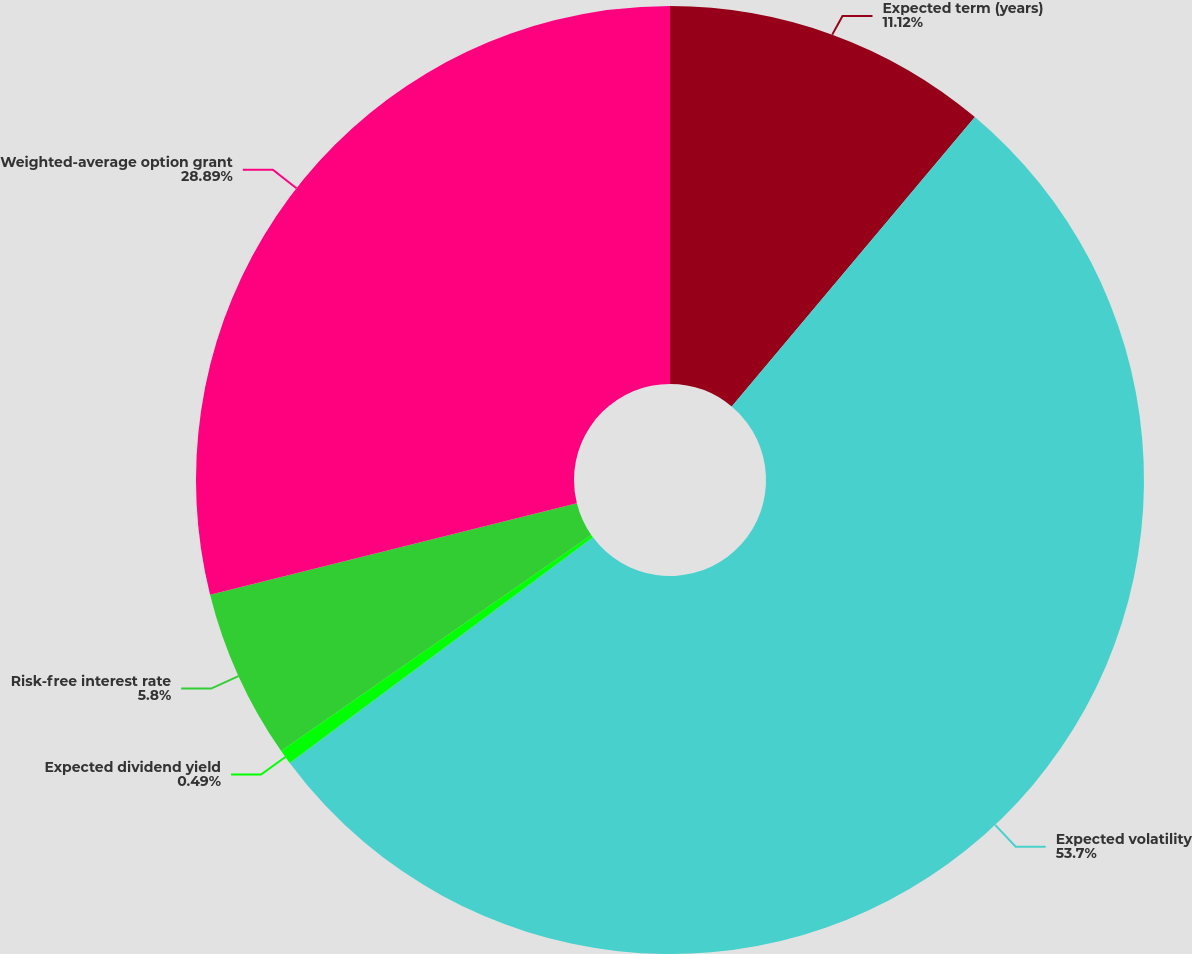<chart> <loc_0><loc_0><loc_500><loc_500><pie_chart><fcel>Expected term (years)<fcel>Expected volatility<fcel>Expected dividend yield<fcel>Risk-free interest rate<fcel>Weighted-average option grant<nl><fcel>11.12%<fcel>53.7%<fcel>0.49%<fcel>5.8%<fcel>28.89%<nl></chart> 